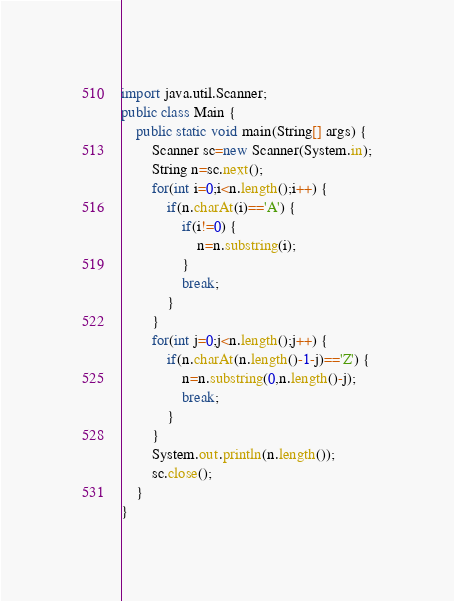<code> <loc_0><loc_0><loc_500><loc_500><_Java_>import java.util.Scanner;
public class Main {
	public static void main(String[] args) {
		Scanner sc=new Scanner(System.in);
		String n=sc.next();
		for(int i=0;i<n.length();i++) {
			if(n.charAt(i)=='A') {
				if(i!=0) {
					n=n.substring(i);
				}
				break;
			}
		}
		for(int j=0;j<n.length();j++) {
			if(n.charAt(n.length()-1-j)=='Z') {
				n=n.substring(0,n.length()-j);
				break;
			}
		}
		System.out.println(n.length());
		sc.close();
	}
}</code> 